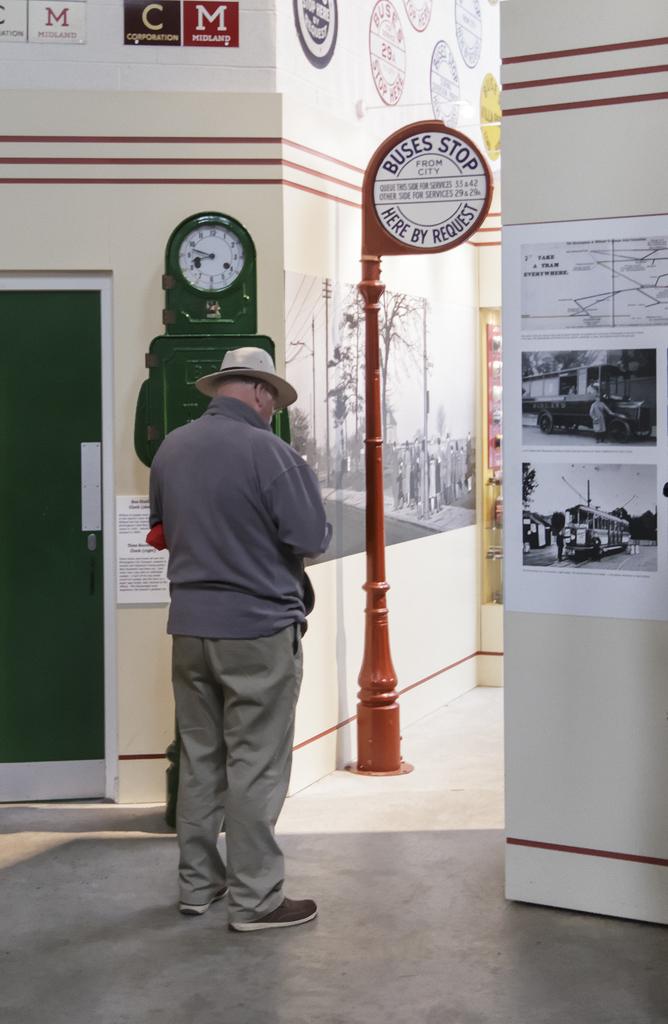What kind of stop is the man at?
Provide a short and direct response. Bus stop. 